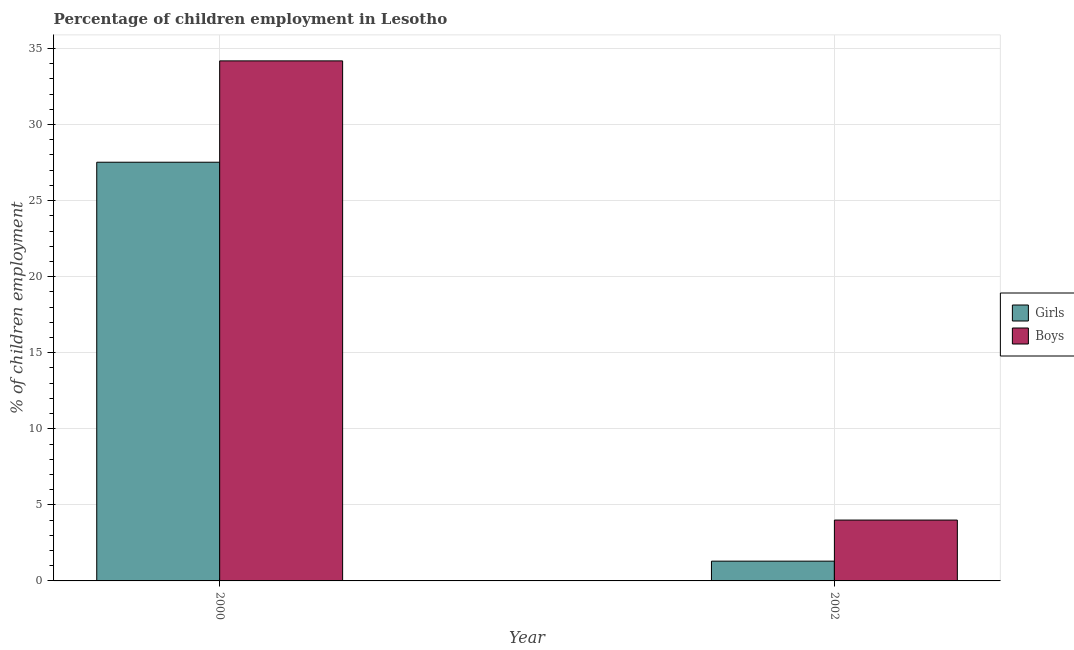What is the label of the 1st group of bars from the left?
Provide a short and direct response. 2000. What is the percentage of employed girls in 2000?
Keep it short and to the point. 27.52. Across all years, what is the maximum percentage of employed boys?
Make the answer very short. 34.18. Across all years, what is the minimum percentage of employed boys?
Provide a succinct answer. 4. In which year was the percentage of employed girls minimum?
Your answer should be compact. 2002. What is the total percentage of employed girls in the graph?
Your answer should be compact. 28.82. What is the difference between the percentage of employed girls in 2000 and that in 2002?
Offer a very short reply. 26.22. What is the difference between the percentage of employed boys in 2000 and the percentage of employed girls in 2002?
Offer a very short reply. 30.18. What is the average percentage of employed boys per year?
Provide a short and direct response. 19.09. In the year 2000, what is the difference between the percentage of employed boys and percentage of employed girls?
Ensure brevity in your answer.  0. What is the ratio of the percentage of employed girls in 2000 to that in 2002?
Keep it short and to the point. 21.17. What does the 2nd bar from the left in 2000 represents?
Give a very brief answer. Boys. What does the 1st bar from the right in 2002 represents?
Provide a short and direct response. Boys. How many bars are there?
Offer a very short reply. 4. How many years are there in the graph?
Ensure brevity in your answer.  2. Are the values on the major ticks of Y-axis written in scientific E-notation?
Provide a succinct answer. No. Does the graph contain grids?
Your response must be concise. Yes. What is the title of the graph?
Offer a terse response. Percentage of children employment in Lesotho. Does "National Tourists" appear as one of the legend labels in the graph?
Keep it short and to the point. No. What is the label or title of the X-axis?
Offer a very short reply. Year. What is the label or title of the Y-axis?
Your answer should be very brief. % of children employment. What is the % of children employment in Girls in 2000?
Provide a succinct answer. 27.52. What is the % of children employment in Boys in 2000?
Your response must be concise. 34.18. What is the % of children employment in Boys in 2002?
Your response must be concise. 4. Across all years, what is the maximum % of children employment in Girls?
Give a very brief answer. 27.52. Across all years, what is the maximum % of children employment in Boys?
Your answer should be compact. 34.18. Across all years, what is the minimum % of children employment in Girls?
Give a very brief answer. 1.3. What is the total % of children employment in Girls in the graph?
Your answer should be compact. 28.82. What is the total % of children employment of Boys in the graph?
Make the answer very short. 38.18. What is the difference between the % of children employment of Girls in 2000 and that in 2002?
Your response must be concise. 26.22. What is the difference between the % of children employment in Boys in 2000 and that in 2002?
Give a very brief answer. 30.18. What is the difference between the % of children employment in Girls in 2000 and the % of children employment in Boys in 2002?
Make the answer very short. 23.52. What is the average % of children employment of Girls per year?
Your answer should be compact. 14.41. What is the average % of children employment in Boys per year?
Your answer should be compact. 19.09. In the year 2000, what is the difference between the % of children employment of Girls and % of children employment of Boys?
Provide a succinct answer. -6.66. In the year 2002, what is the difference between the % of children employment in Girls and % of children employment in Boys?
Your answer should be compact. -2.7. What is the ratio of the % of children employment of Girls in 2000 to that in 2002?
Provide a short and direct response. 21.17. What is the ratio of the % of children employment in Boys in 2000 to that in 2002?
Make the answer very short. 8.55. What is the difference between the highest and the second highest % of children employment of Girls?
Give a very brief answer. 26.22. What is the difference between the highest and the second highest % of children employment of Boys?
Provide a short and direct response. 30.18. What is the difference between the highest and the lowest % of children employment in Girls?
Your response must be concise. 26.22. What is the difference between the highest and the lowest % of children employment of Boys?
Keep it short and to the point. 30.18. 